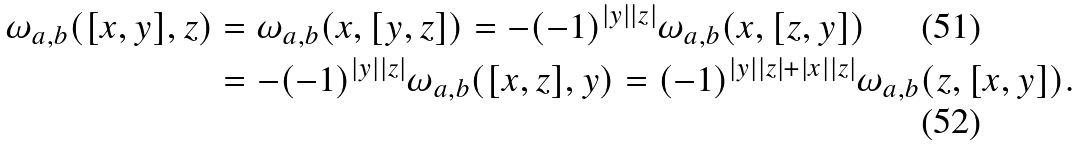<formula> <loc_0><loc_0><loc_500><loc_500>\omega _ { a , b } ( [ x , y ] , z ) & = \omega _ { a , b } ( x , [ y , z ] ) = - ( - 1 ) ^ { | y | | z | } \omega _ { a , b } ( x , [ z , y ] ) \\ & = - ( - 1 ) ^ { | y | | z | } \omega _ { a , b } ( [ x , z ] , y ) = ( - 1 ) ^ { | y | | z | + | x | | z | } \omega _ { a , b } ( z , [ x , y ] ) .</formula> 